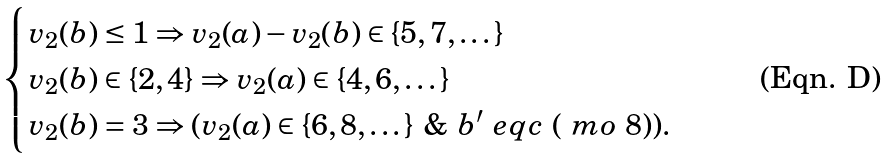<formula> <loc_0><loc_0><loc_500><loc_500>\begin{cases} v _ { 2 } ( b ) \leq 1 \Rightarrow v _ { 2 } ( a ) - v _ { 2 } ( b ) \in \{ 5 , 7 , \dots \} & \\ v _ { 2 } ( b ) \in \{ 2 , 4 \} \Rightarrow v _ { 2 } ( a ) \in \{ 4 , 6 , \dots \} & \\ v _ { 2 } ( b ) = 3 \Rightarrow ( v _ { 2 } ( a ) \in \{ 6 , 8 , \dots \} \ \& \ b ^ { \prime } \ e q c \ ( \ m o \ 8 ) ) . \end{cases}</formula> 